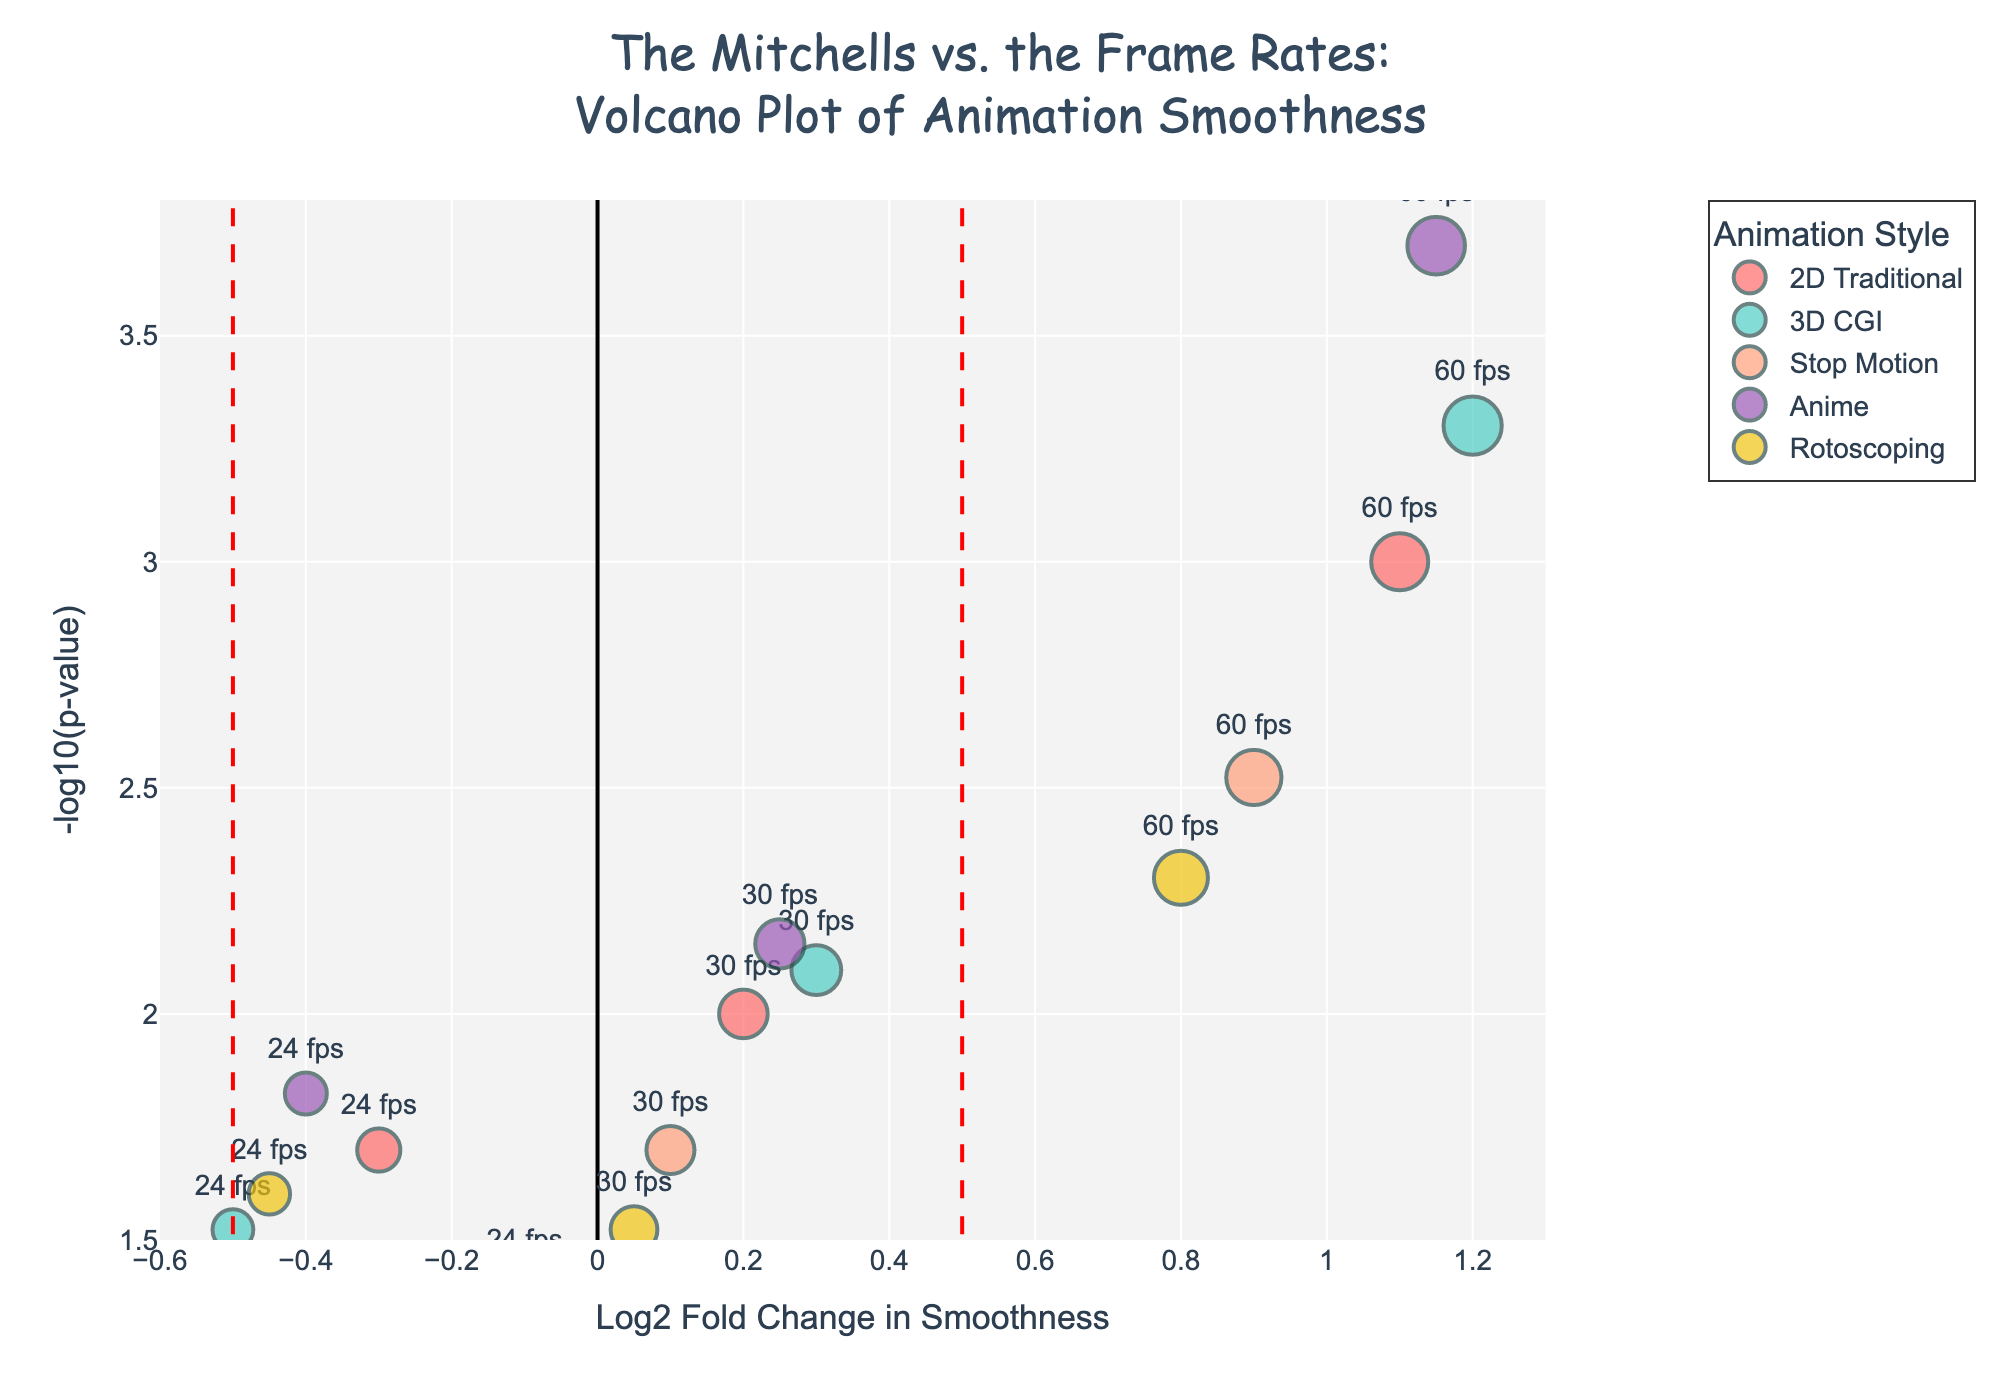What is the title of the volcano plot? The title is found at the top of the figure and provides context about the dataset and purpose of the plot.
Answer: The Mitchells vs. the Frame Rates: Volcano Plot of Animation Smoothness What does the x-axis represent on the volcano plot? The x-axis is labeled with the variable it represents; in this case, it's "Log2 Fold Change in Smoothness," indicating the logarithm base 2 of the change in smoothness.
Answer: Log2 Fold Change in Smoothness Which animation style is represented by the color purple? The color purple in the legend corresponds to one of the animation styles. Checking the legend, purple represents Anime.
Answer: Anime How many data points are there for each animation style? Each unique marker in the plot represents a data point. By counting the markers or referring to the hover information, there are three data points per animation style.
Answer: Three data points per animation style Which frame rate of '3D CGI' has the highest perceived smoothness score? Hover over the points or read the hover text to find '3D CGI' data points and their smoothness scores. The highest smoothness score for '3D CGI' corresponds to the 60 fps data point with a score of 9.7.
Answer: 60 fps What frame rate is indicated by the point with the highest log2 fold change in the dataset? The highest log2 fold change on the x-axis is 1.2, which corresponds to the 60 fps point for '3D CGI' as per the hover text.
Answer: 60 fps How does the significance (p-value) vary between frame rates? By observing the y-axis (-log10(p-value)), smaller p-values correspond to higher points on the y-axis. 60 fps consistently shows higher significance with lower p-values compared to 24 fps and 30 fps across animation styles.
Answer: Higher frame rates (60 fps) generally show higher significance What is the color and position of the point representing the 60 fps for ‘Stop Motion’? The 60 fps for 'Stop Motion' can be determined by checking color (orange) and its location using the 'smoothness score' factor and log2 fold change (0.9, ~10010^-3 p-value).
Answer: Orange and in the upper right quadrant Which animation style shows the least change in smoothness compared to the baseline at 24 fps? Look for data points closest to the center on the x-axis for minimal change. 'Stop Motion' at 30 fps has a log2 fold change of 0.1, the smallest positive change.
Answer: Stop Motion at 30 fps Which frame rate shows the most significant increase in smoothness for 'Rotoscoping'? From the positions on the plot, 'Rotoscoping' points on the right side of the plot show increase. The most significant, with high y-axis value and far-right x-axis value is 60 fps with a log2 fold change of 0.8.
Answer: 60 fps 